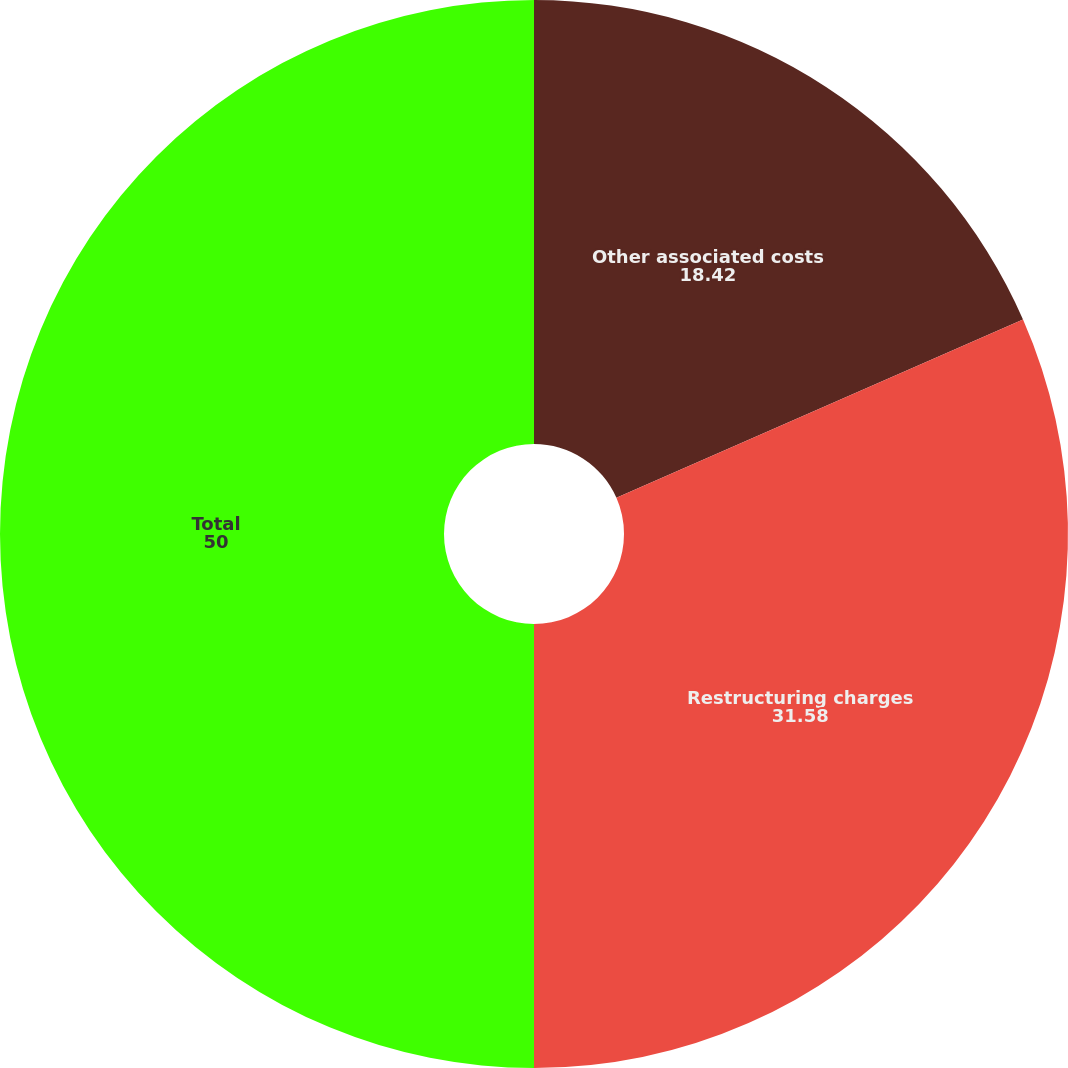Convert chart. <chart><loc_0><loc_0><loc_500><loc_500><pie_chart><fcel>Other associated costs<fcel>Restructuring charges<fcel>Total<nl><fcel>18.42%<fcel>31.58%<fcel>50.0%<nl></chart> 